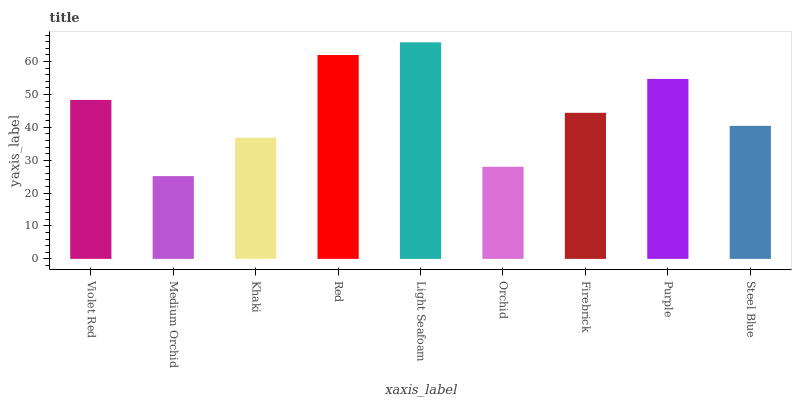Is Khaki the minimum?
Answer yes or no. No. Is Khaki the maximum?
Answer yes or no. No. Is Khaki greater than Medium Orchid?
Answer yes or no. Yes. Is Medium Orchid less than Khaki?
Answer yes or no. Yes. Is Medium Orchid greater than Khaki?
Answer yes or no. No. Is Khaki less than Medium Orchid?
Answer yes or no. No. Is Firebrick the high median?
Answer yes or no. Yes. Is Firebrick the low median?
Answer yes or no. Yes. Is Orchid the high median?
Answer yes or no. No. Is Medium Orchid the low median?
Answer yes or no. No. 